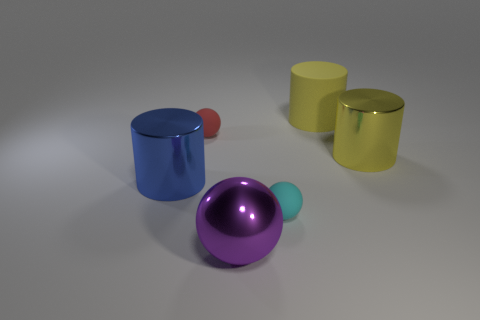Add 1 yellow matte cylinders. How many objects exist? 7 Subtract all large yellow metal cylinders. Subtract all balls. How many objects are left? 2 Add 2 small spheres. How many small spheres are left? 4 Add 6 small yellow metal cubes. How many small yellow metal cubes exist? 6 Subtract 0 gray cylinders. How many objects are left? 6 